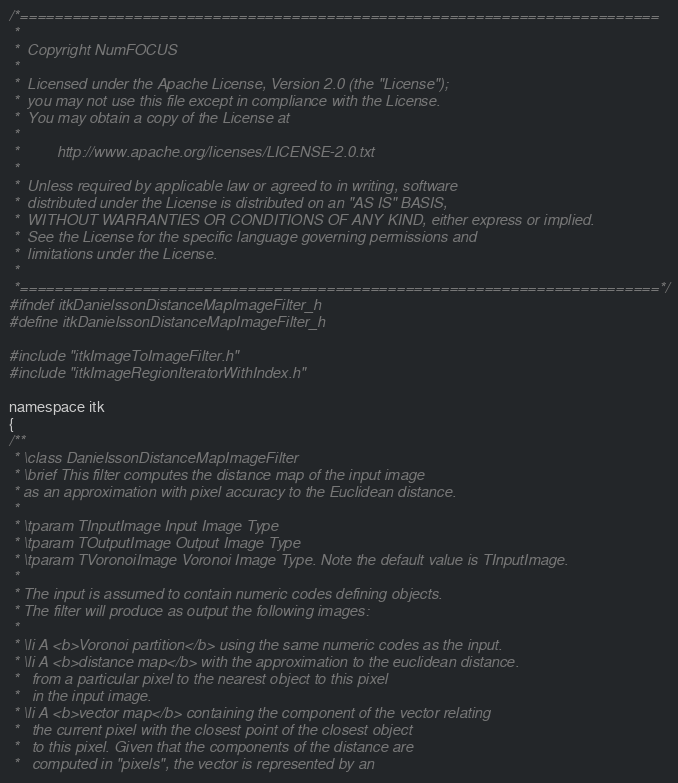<code> <loc_0><loc_0><loc_500><loc_500><_C_>/*=========================================================================
 *
 *  Copyright NumFOCUS
 *
 *  Licensed under the Apache License, Version 2.0 (the "License");
 *  you may not use this file except in compliance with the License.
 *  You may obtain a copy of the License at
 *
 *         http://www.apache.org/licenses/LICENSE-2.0.txt
 *
 *  Unless required by applicable law or agreed to in writing, software
 *  distributed under the License is distributed on an "AS IS" BASIS,
 *  WITHOUT WARRANTIES OR CONDITIONS OF ANY KIND, either express or implied.
 *  See the License for the specific language governing permissions and
 *  limitations under the License.
 *
 *=========================================================================*/
#ifndef itkDanielssonDistanceMapImageFilter_h
#define itkDanielssonDistanceMapImageFilter_h

#include "itkImageToImageFilter.h"
#include "itkImageRegionIteratorWithIndex.h"

namespace itk
{
/**
 * \class DanielssonDistanceMapImageFilter
 * \brief This filter computes the distance map of the input image
 * as an approximation with pixel accuracy to the Euclidean distance.
 *
 * \tparam TInputImage Input Image Type
 * \tparam TOutputImage Output Image Type
 * \tparam TVoronoiImage Voronoi Image Type. Note the default value is TInputImage.
 *
 * The input is assumed to contain numeric codes defining objects.
 * The filter will produce as output the following images:
 *
 * \li A <b>Voronoi partition</b> using the same numeric codes as the input.
 * \li A <b>distance map</b> with the approximation to the euclidean distance.
 *   from a particular pixel to the nearest object to this pixel
 *   in the input image.
 * \li A <b>vector map</b> containing the component of the vector relating
 *   the current pixel with the closest point of the closest object
 *   to this pixel. Given that the components of the distance are
 *   computed in "pixels", the vector is represented by an</code> 